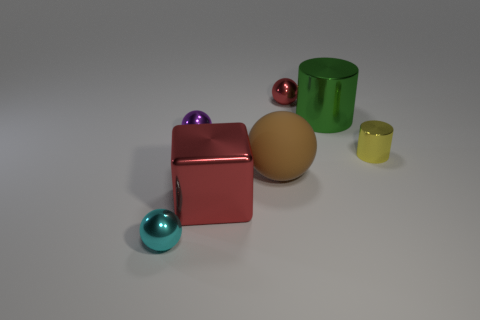How many large things are the same shape as the small red object? There is one large object that shares the same cubic shape as the small red object in the image. 